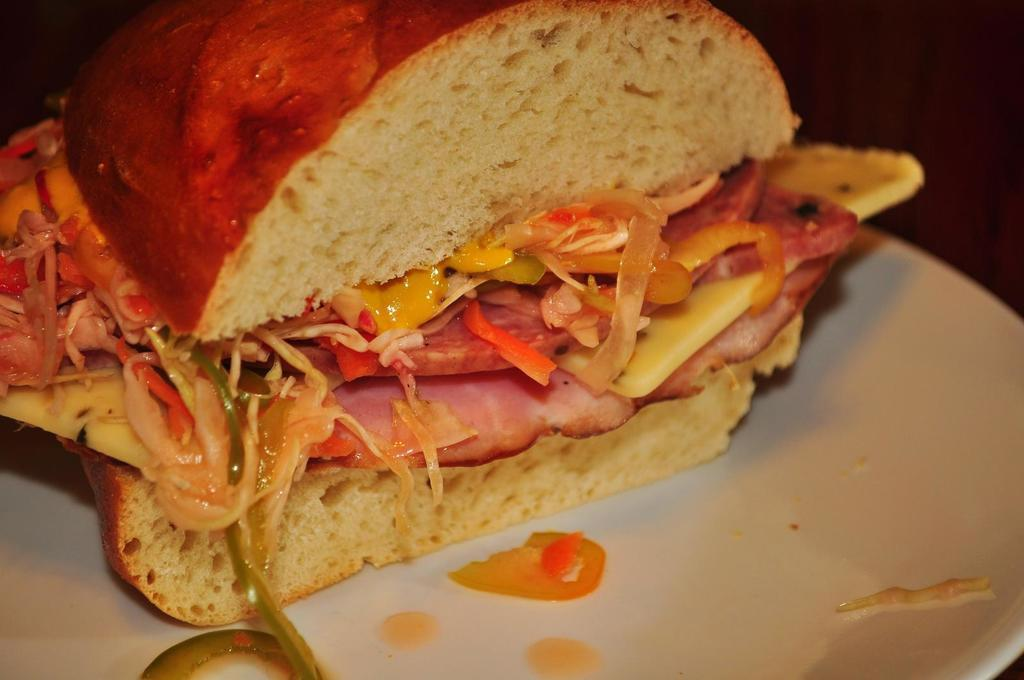What type of food can be seen in the image? There is a fast food item in the image. How is the fast food item presented? The fast food item is placed on a white plate. How many beds are visible in the image? There are no beds present in the image; it features a fast food item on a white plate. What type of humor can be seen in the image? There is no humor depicted in the image; it is a straightforward presentation of a fast food item on a white plate. 